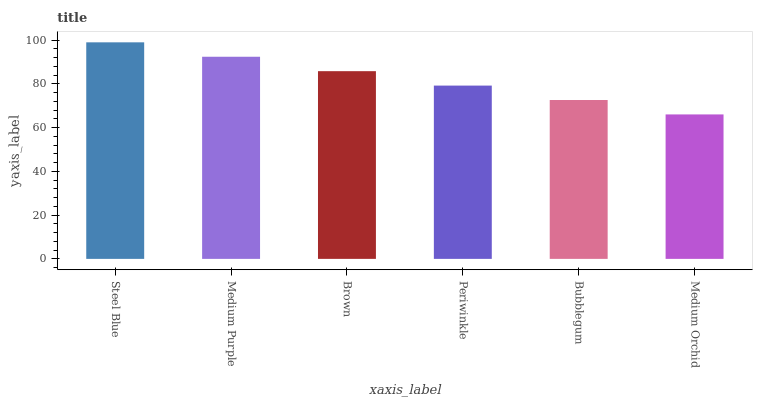Is Medium Orchid the minimum?
Answer yes or no. Yes. Is Steel Blue the maximum?
Answer yes or no. Yes. Is Medium Purple the minimum?
Answer yes or no. No. Is Medium Purple the maximum?
Answer yes or no. No. Is Steel Blue greater than Medium Purple?
Answer yes or no. Yes. Is Medium Purple less than Steel Blue?
Answer yes or no. Yes. Is Medium Purple greater than Steel Blue?
Answer yes or no. No. Is Steel Blue less than Medium Purple?
Answer yes or no. No. Is Brown the high median?
Answer yes or no. Yes. Is Periwinkle the low median?
Answer yes or no. Yes. Is Medium Orchid the high median?
Answer yes or no. No. Is Bubblegum the low median?
Answer yes or no. No. 